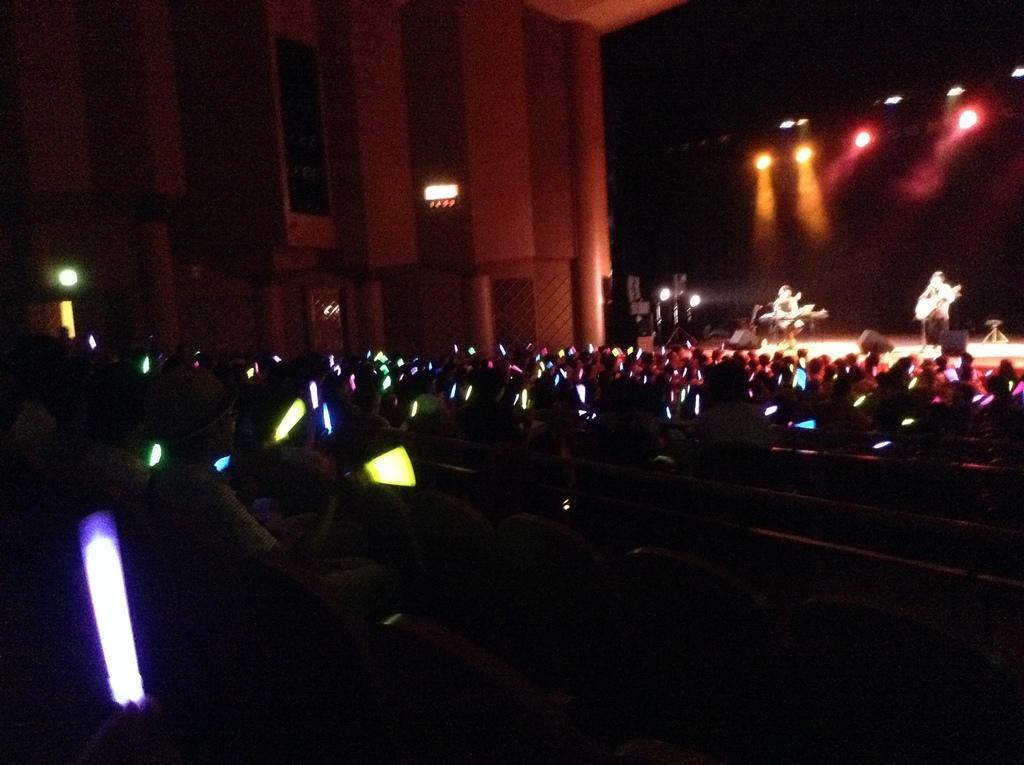Describe this image in one or two sentences. This picture describes about group of people, in this we can find few people are playing musical instruments on the stage, and also we can find few lights. 